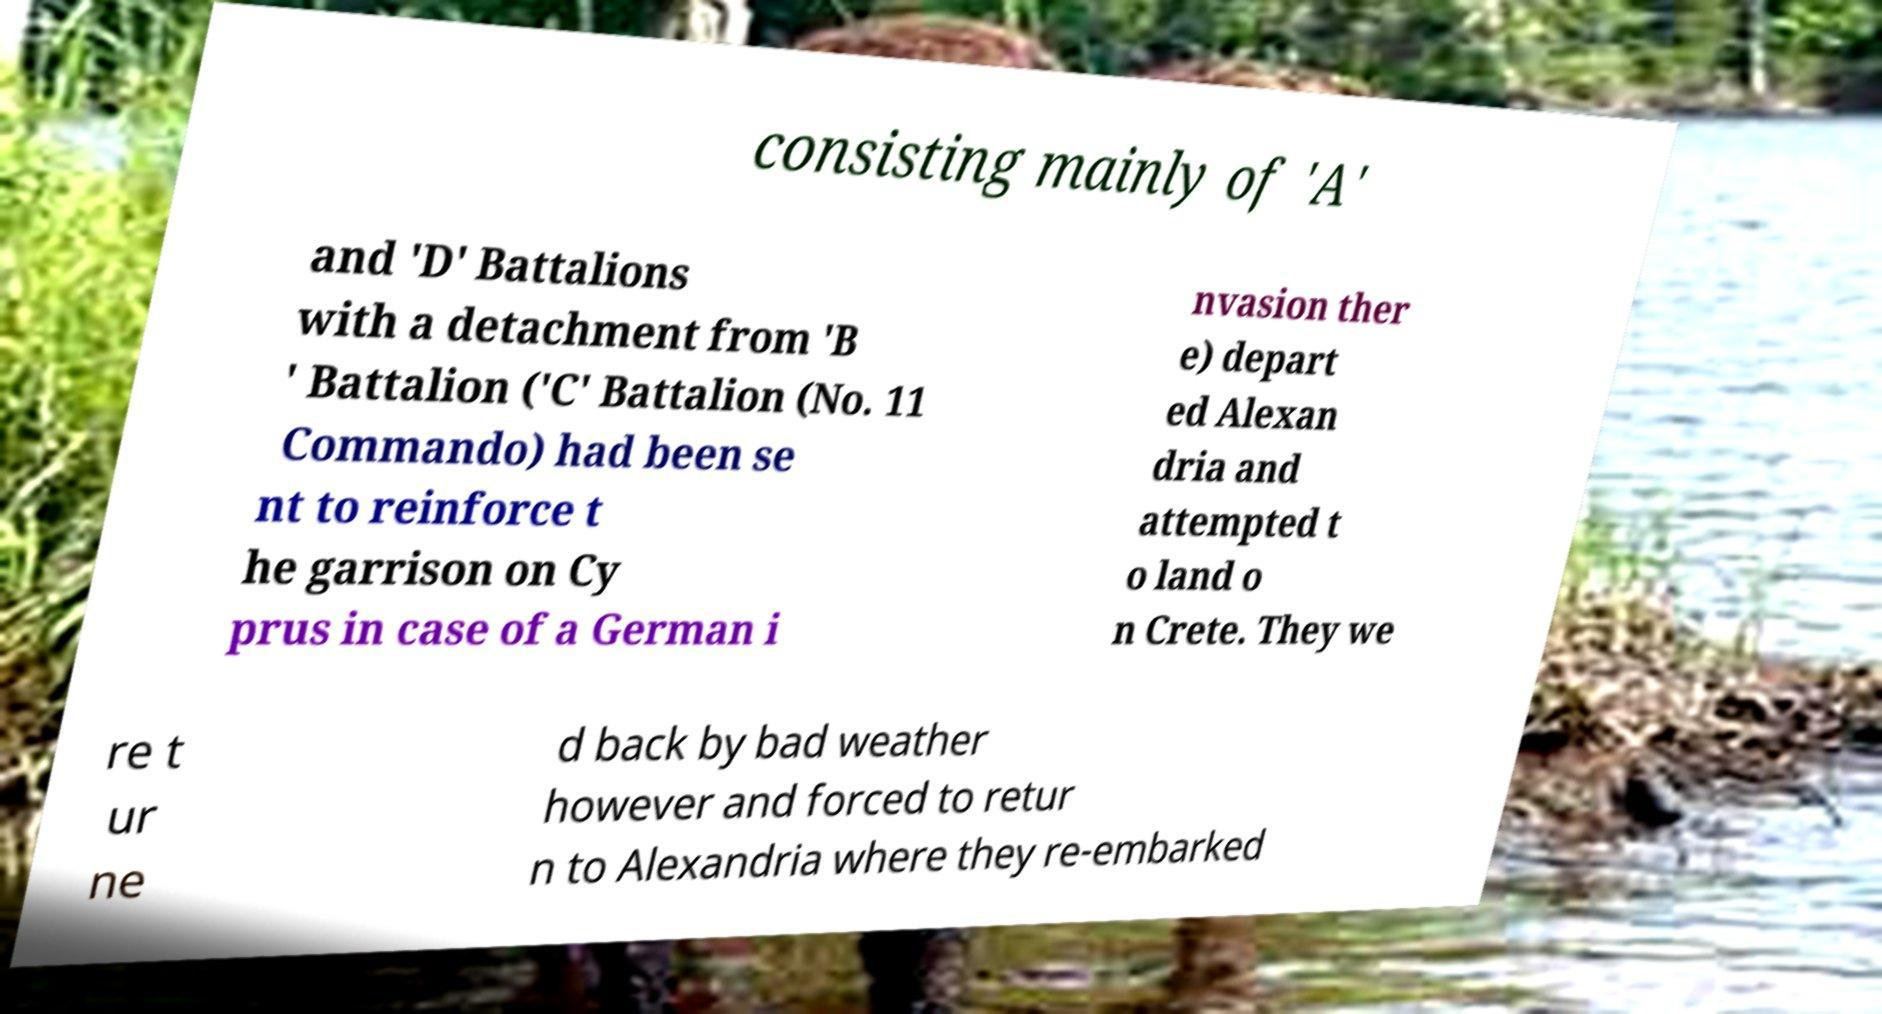Could you extract and type out the text from this image? consisting mainly of 'A' and 'D' Battalions with a detachment from 'B ' Battalion ('C' Battalion (No. 11 Commando) had been se nt to reinforce t he garrison on Cy prus in case of a German i nvasion ther e) depart ed Alexan dria and attempted t o land o n Crete. They we re t ur ne d back by bad weather however and forced to retur n to Alexandria where they re-embarked 